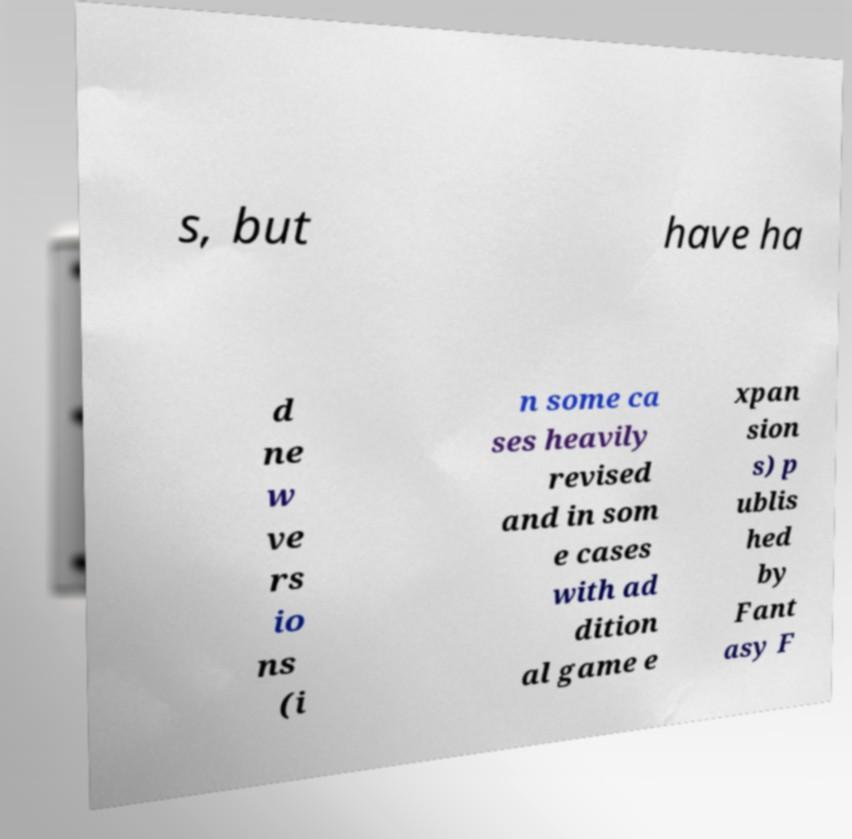I need the written content from this picture converted into text. Can you do that? s, but have ha d ne w ve rs io ns (i n some ca ses heavily revised and in som e cases with ad dition al game e xpan sion s) p ublis hed by Fant asy F 